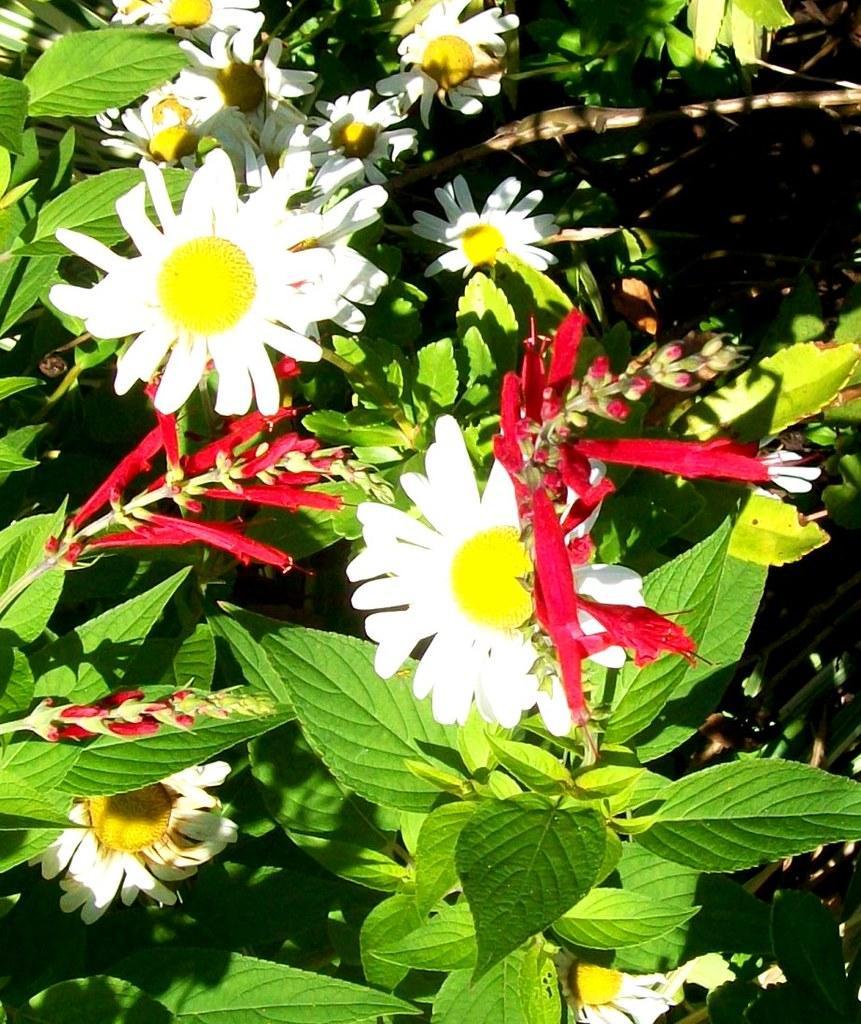In one or two sentences, can you explain what this image depicts? In this image I can see there are plants and flowers and buds on it. 